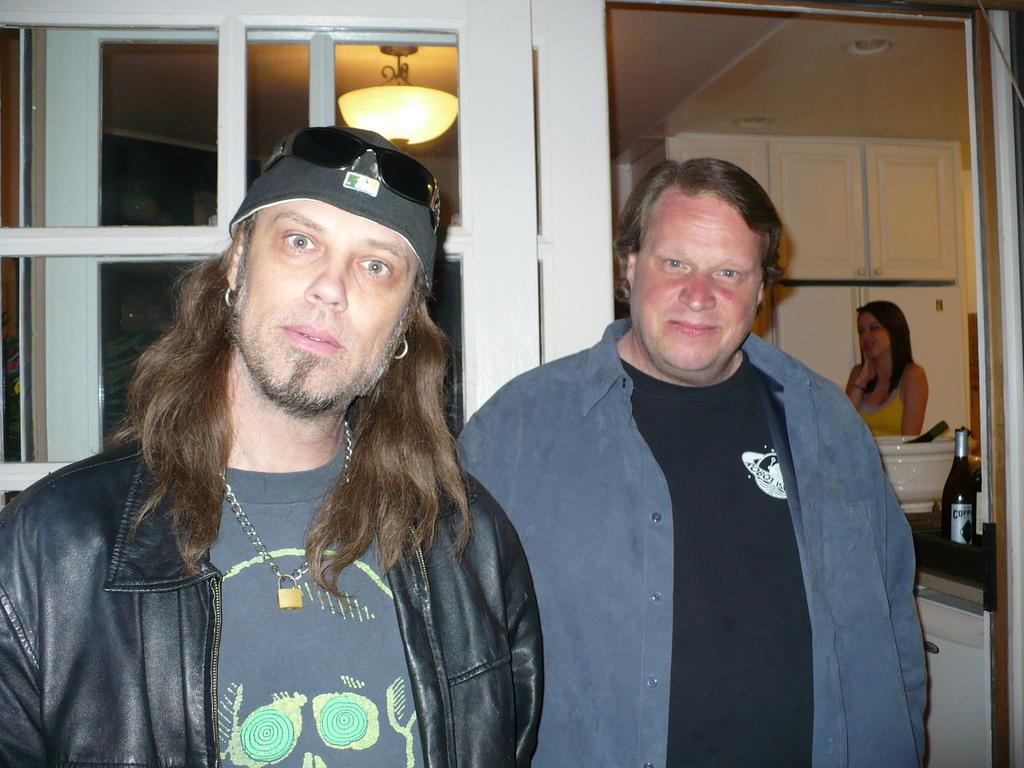How many people are in the image? There are two persons in the image. What are the persons wearing? The persons are wearing clothes. What object can be seen on the right side of the image? There is a bottle on the right side of the image. What is the source of light in the image? There is a light at the top of the image. Can you see any bats flying around in the image? There are no bats visible in the image. How many ladybugs are crawling on the persons' clothes in the image? There are no ladybugs present in the image. 